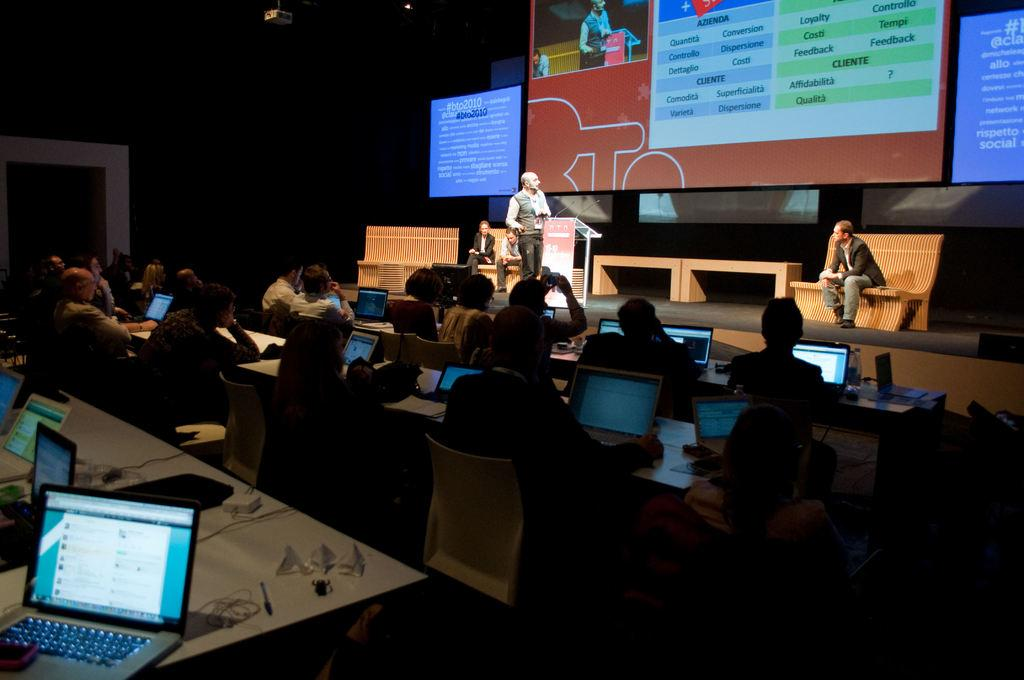<image>
Give a short and clear explanation of the subsequent image. An instructor stands next to a podium labeled BTO as students listen. 